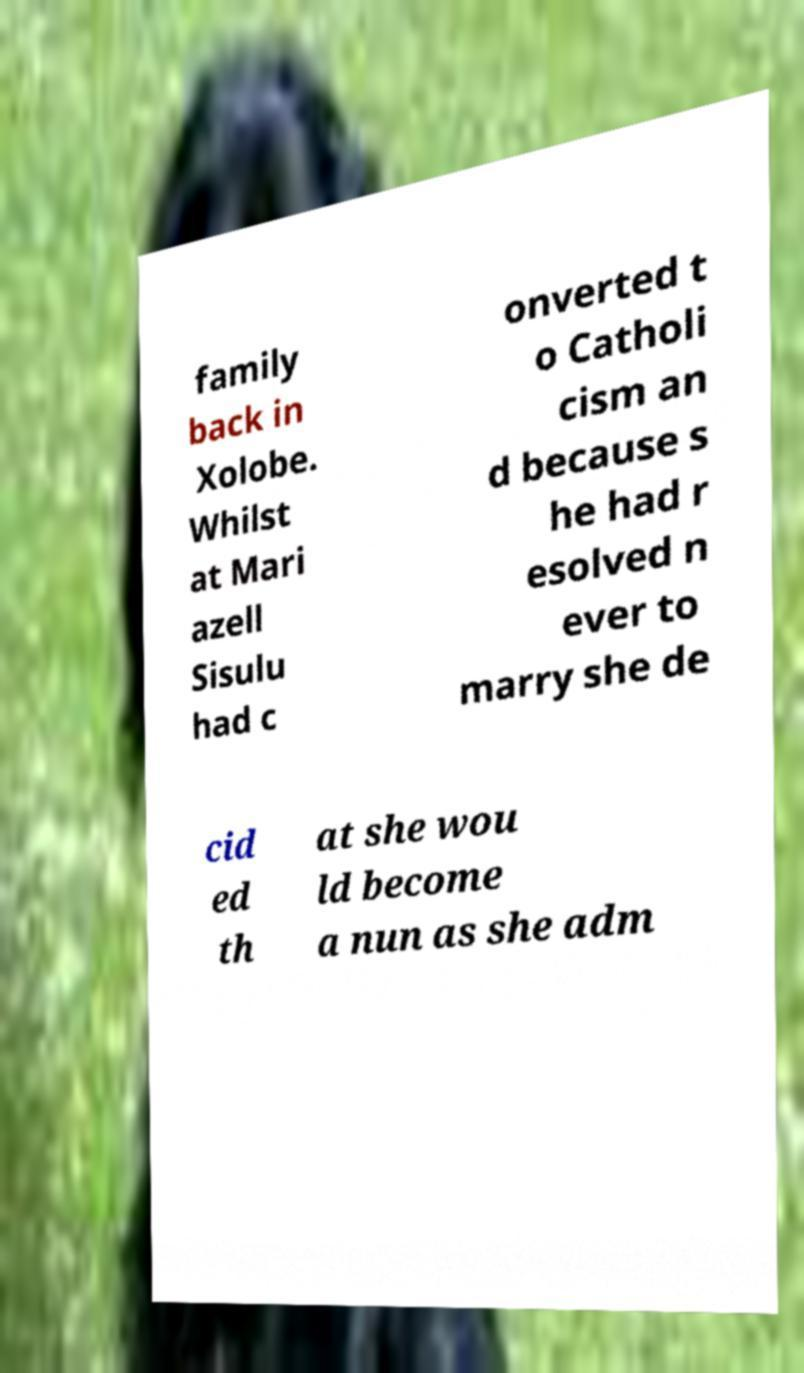What messages or text are displayed in this image? I need them in a readable, typed format. family back in Xolobe. Whilst at Mari azell Sisulu had c onverted t o Catholi cism an d because s he had r esolved n ever to marry she de cid ed th at she wou ld become a nun as she adm 